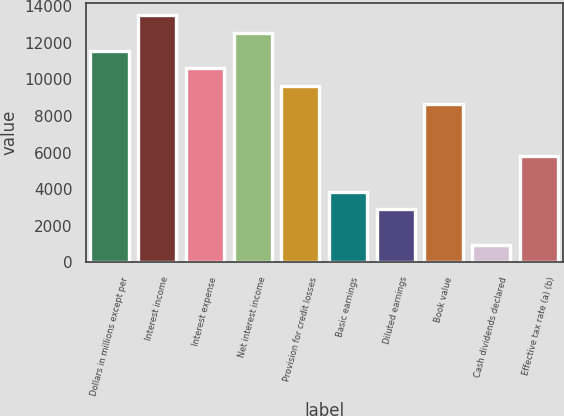Convert chart. <chart><loc_0><loc_0><loc_500><loc_500><bar_chart><fcel>Dollars in millions except per<fcel>Interest income<fcel>Interest expense<fcel>Net interest income<fcel>Provision for credit losses<fcel>Basic earnings<fcel>Diluted earnings<fcel>Book value<fcel>Cash dividends declared<fcel>Effective tax rate (a) (b)<nl><fcel>11582.2<fcel>13512.4<fcel>10617.1<fcel>12547.3<fcel>9652<fcel>3861.46<fcel>2896.37<fcel>8686.91<fcel>966.19<fcel>5791.64<nl></chart> 